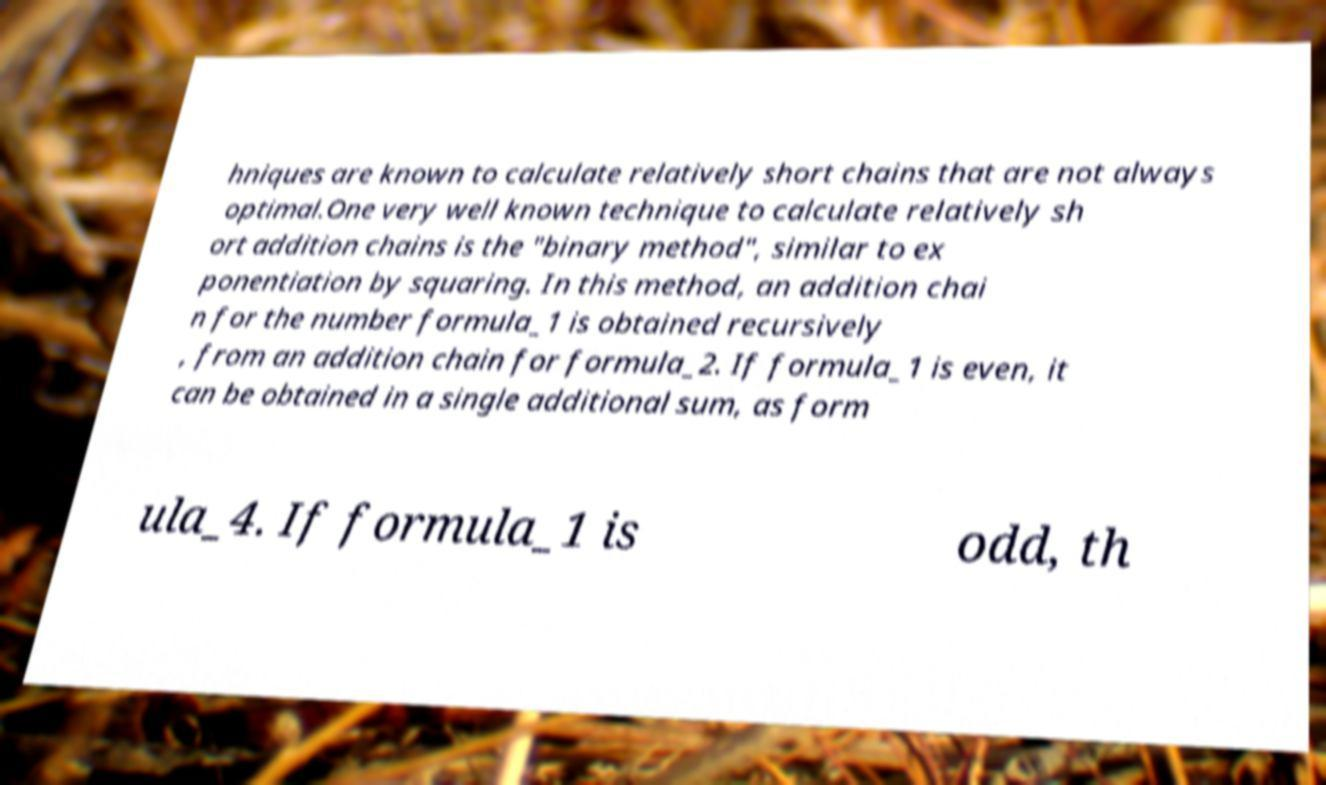Please read and relay the text visible in this image. What does it say? hniques are known to calculate relatively short chains that are not always optimal.One very well known technique to calculate relatively sh ort addition chains is the "binary method", similar to ex ponentiation by squaring. In this method, an addition chai n for the number formula_1 is obtained recursively , from an addition chain for formula_2. If formula_1 is even, it can be obtained in a single additional sum, as form ula_4. If formula_1 is odd, th 